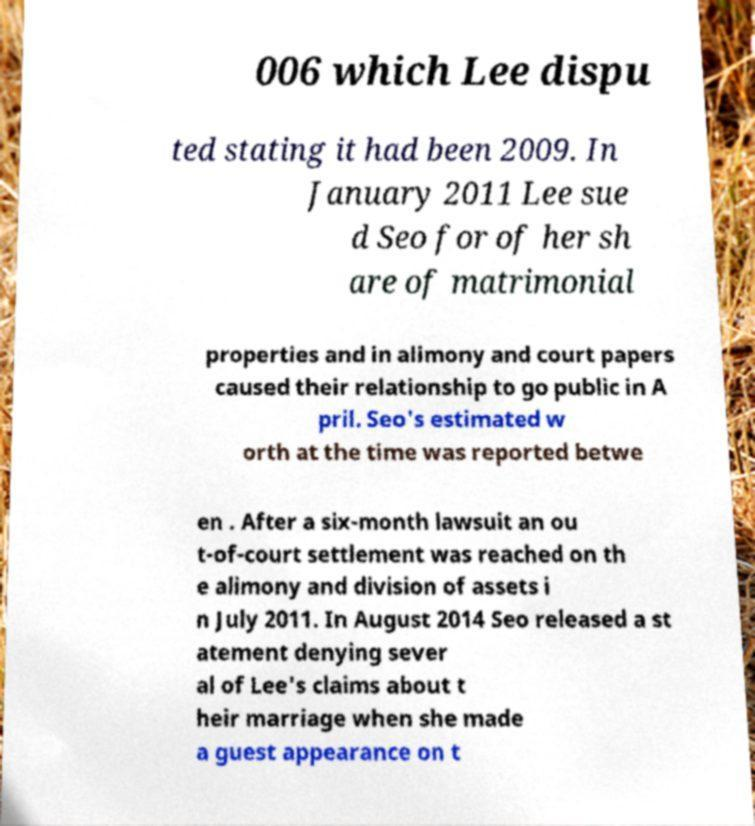Can you accurately transcribe the text from the provided image for me? 006 which Lee dispu ted stating it had been 2009. In January 2011 Lee sue d Seo for of her sh are of matrimonial properties and in alimony and court papers caused their relationship to go public in A pril. Seo's estimated w orth at the time was reported betwe en . After a six-month lawsuit an ou t-of-court settlement was reached on th e alimony and division of assets i n July 2011. In August 2014 Seo released a st atement denying sever al of Lee's claims about t heir marriage when she made a guest appearance on t 